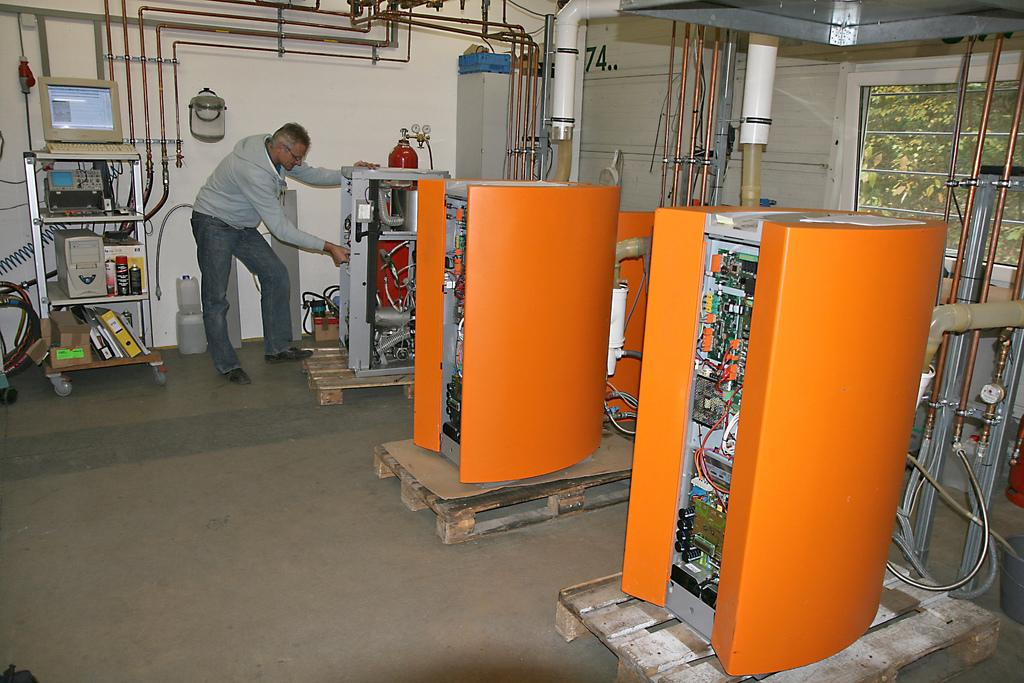Provide a one-sentence caption for the provided image. A man works on a unit in a building with orange electrical units and an old style computer on a shelf. 